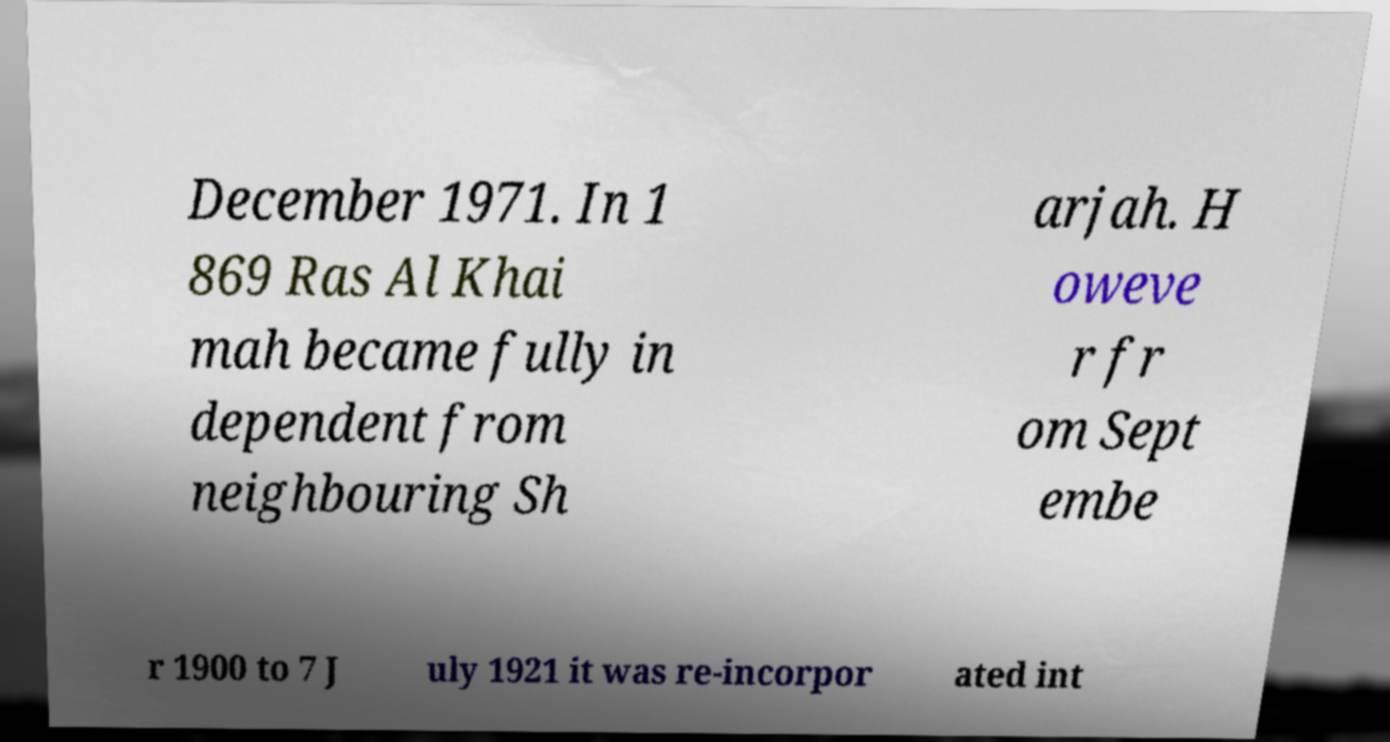For documentation purposes, I need the text within this image transcribed. Could you provide that? December 1971. In 1 869 Ras Al Khai mah became fully in dependent from neighbouring Sh arjah. H oweve r fr om Sept embe r 1900 to 7 J uly 1921 it was re-incorpor ated int 